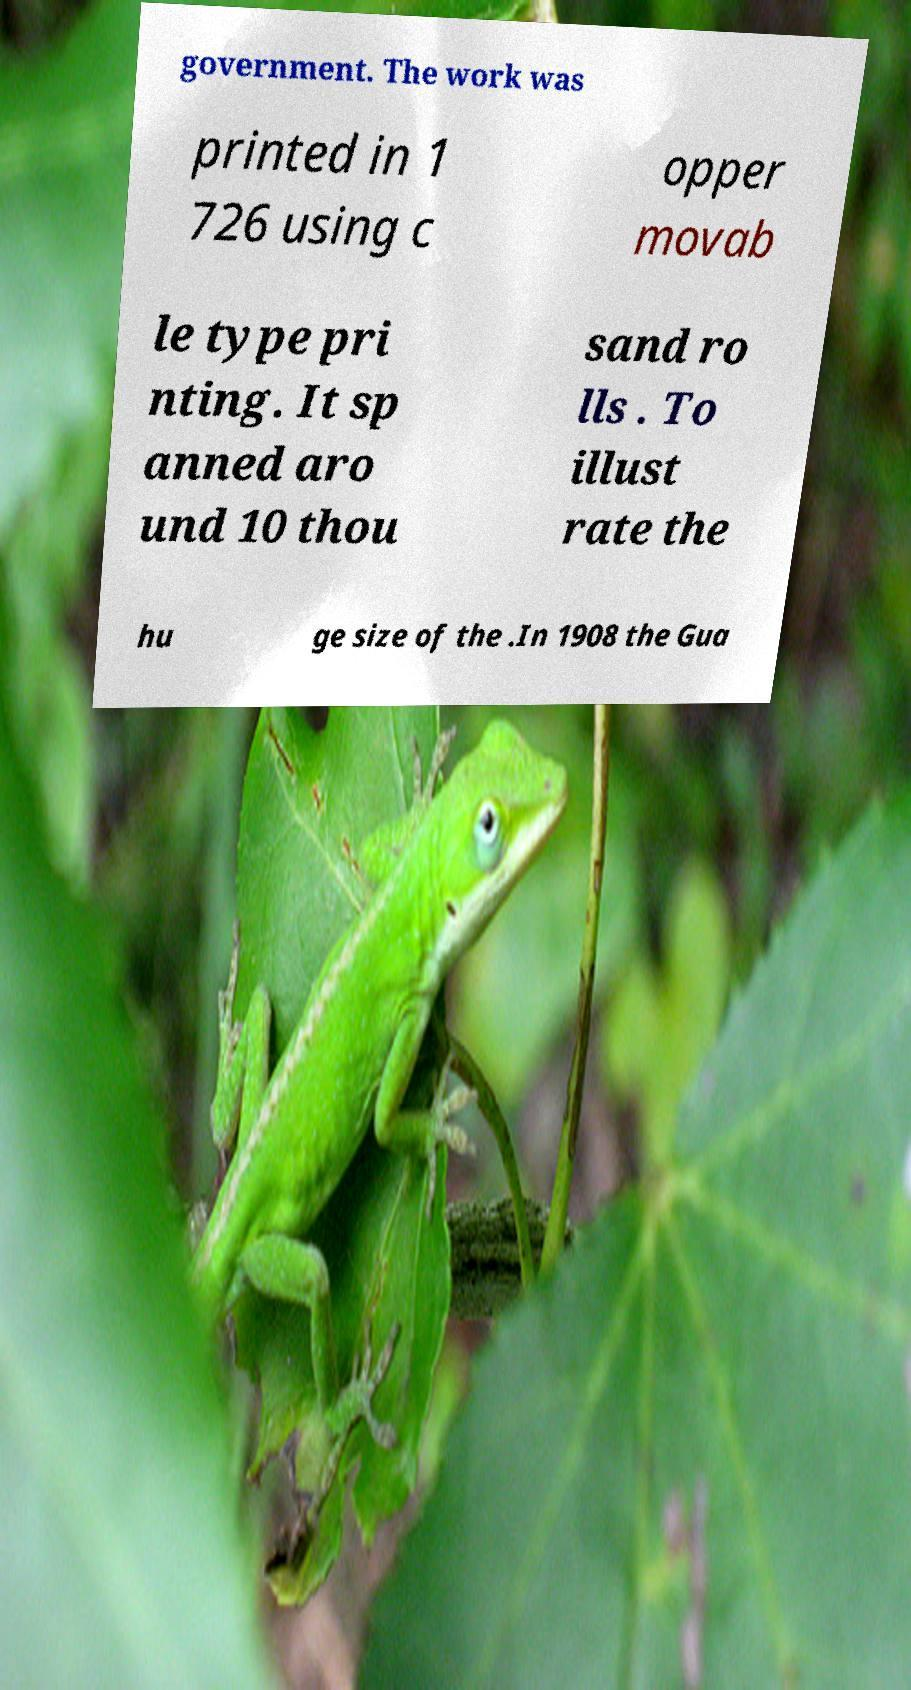Can you read and provide the text displayed in the image?This photo seems to have some interesting text. Can you extract and type it out for me? government. The work was printed in 1 726 using c opper movab le type pri nting. It sp anned aro und 10 thou sand ro lls . To illust rate the hu ge size of the .In 1908 the Gua 